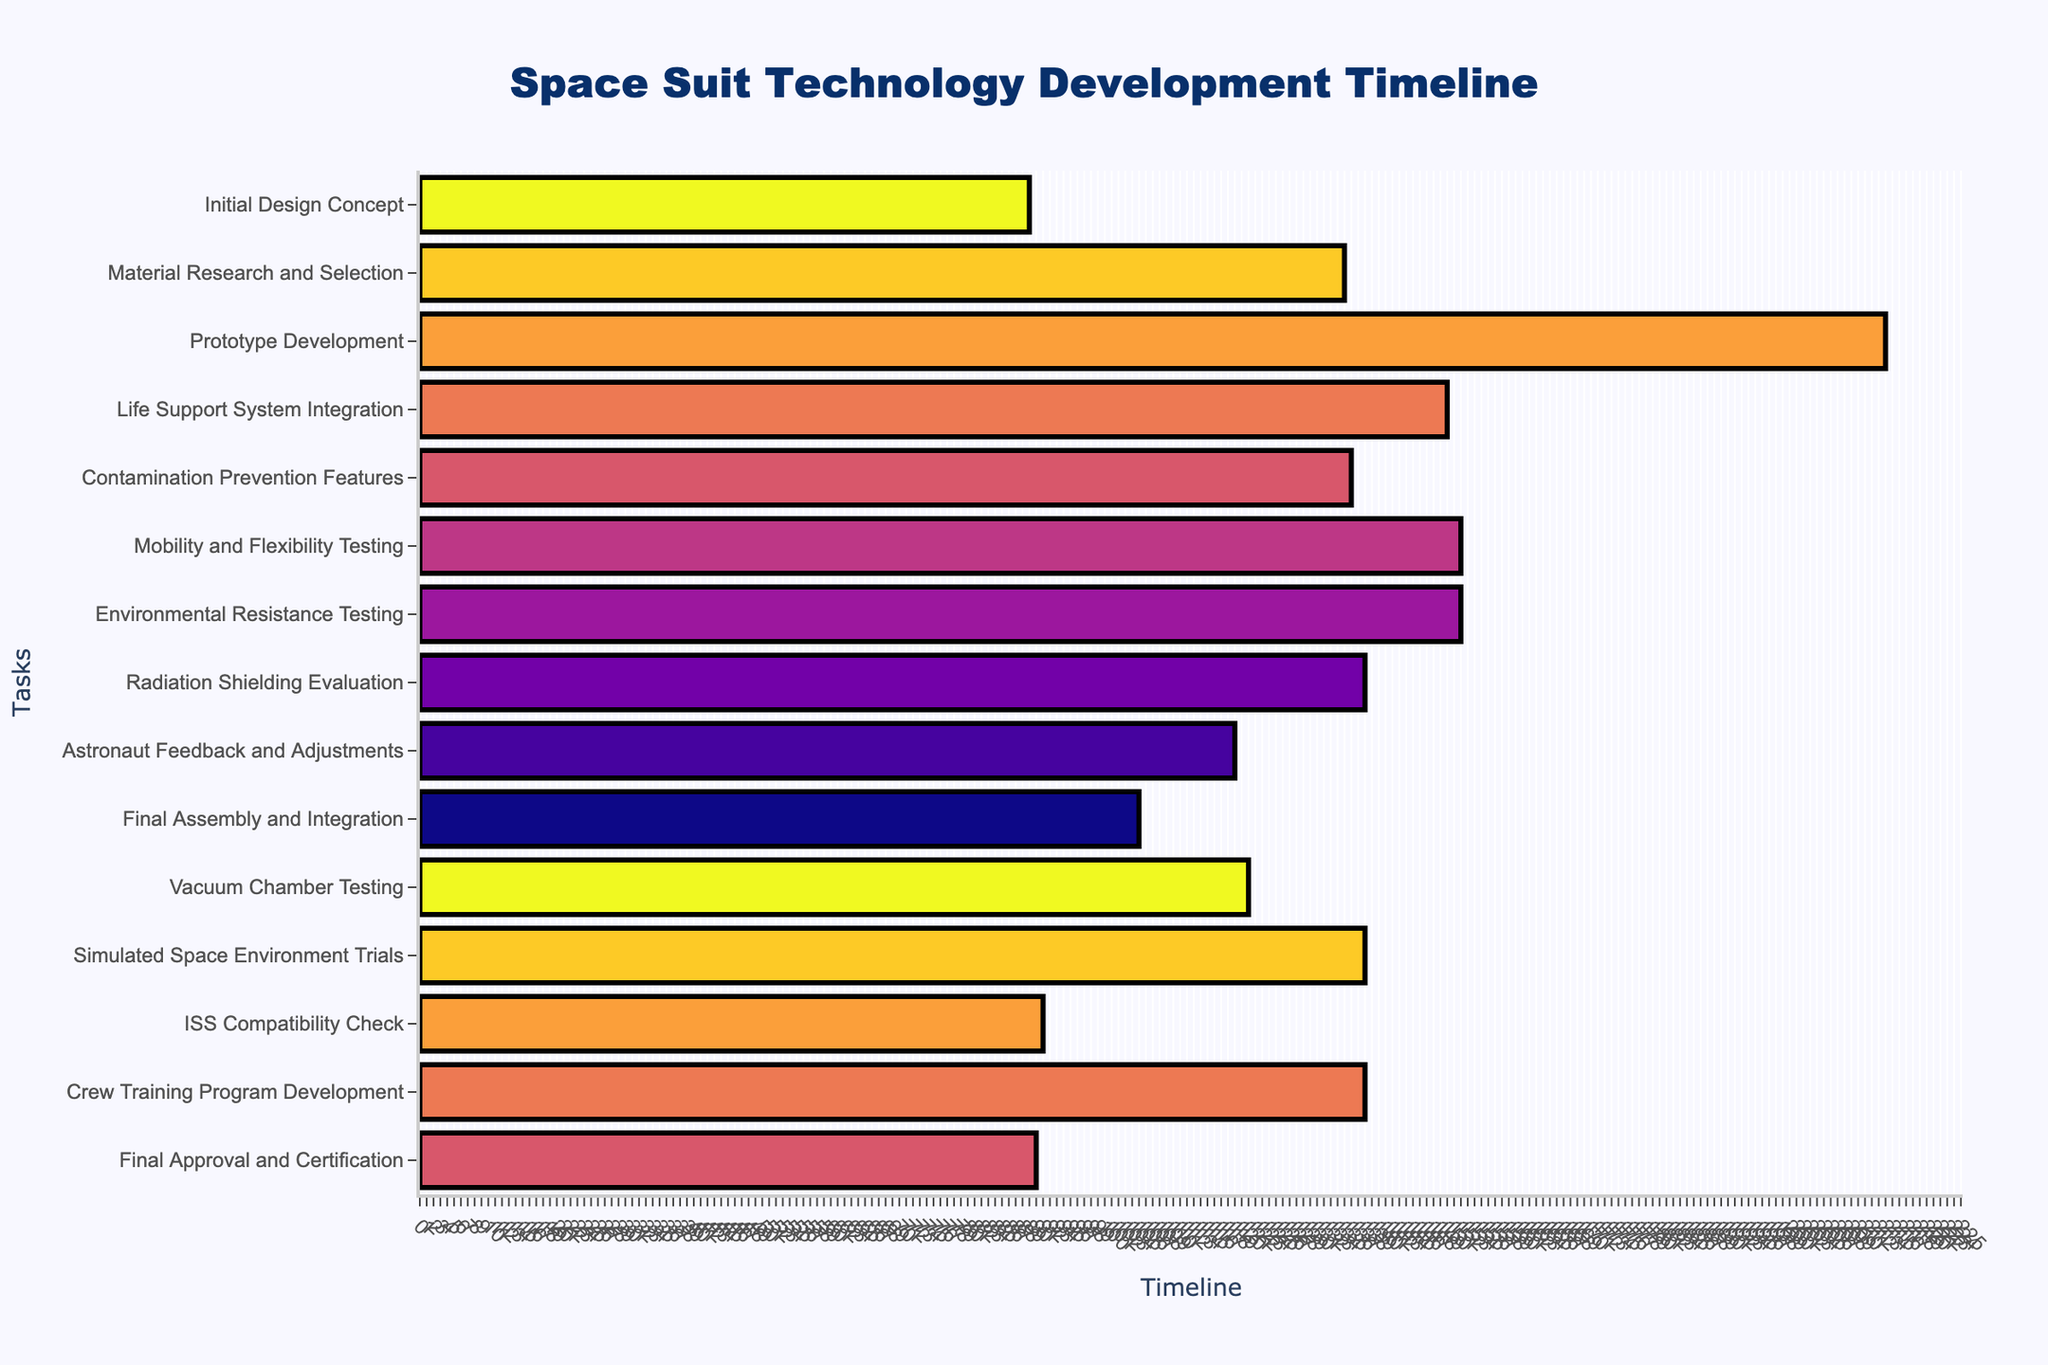What's the title of the Gantt chart? The title is displayed prominently at the top of the chart.
Answer: Space Suit Technology Development Timeline Which task starts first according to the Gantt chart? The start date of each task is visualized using horizontal bars. The first task starts on 2025-01-01.
Answer: Initial Design Concept How many tasks have end dates in the year 2027? By examining the end dates of the horizontal bars and noting when they correspond to 2027, we can count the tasks.
Answer: Five tasks Which task takes the longest duration? We need to measure the length of the horizontal bars and find the one that spans the most on the timeline axis.
Answer: Prototype Development When does the "Radiation Shielding Evaluation" task begin and end? The text hover information or the end of the horizontal bar shows start and end dates.
Answer: Starts on 2026-08-15 and ends on 2026-12-31 Which tasks overlap with the "Material Research and Selection" phase? Identify the tasks by comparing the start and end dates of "Material Research and Selection" (2025-02-15 to 2025-06-30) to other tasks' dates.
Answer: Initial Design Concept, Prototype Development, Life Support System Integration How long is the "Crew Training Program Development" task? Compute the duration from start to end dates of the task (2027-09-15 to 2028-01-31).
Answer: 138 days Which tasks are scheduled to start in January 2027? Identify bars that have a start date in January 2027 by examining the dates.
Answer: Final Assembly and Integration What two tasks are running simultaneously during March 2026? Identify the tasks by comparing their start and end dates to see if they include March 2026.
Answer: Life Support System Integration and Contamination Prevention Features Which task is scheduled to end last? Find the task with the latest end date on the chart, towards the far right.
Answer: Final Approval and Certification 